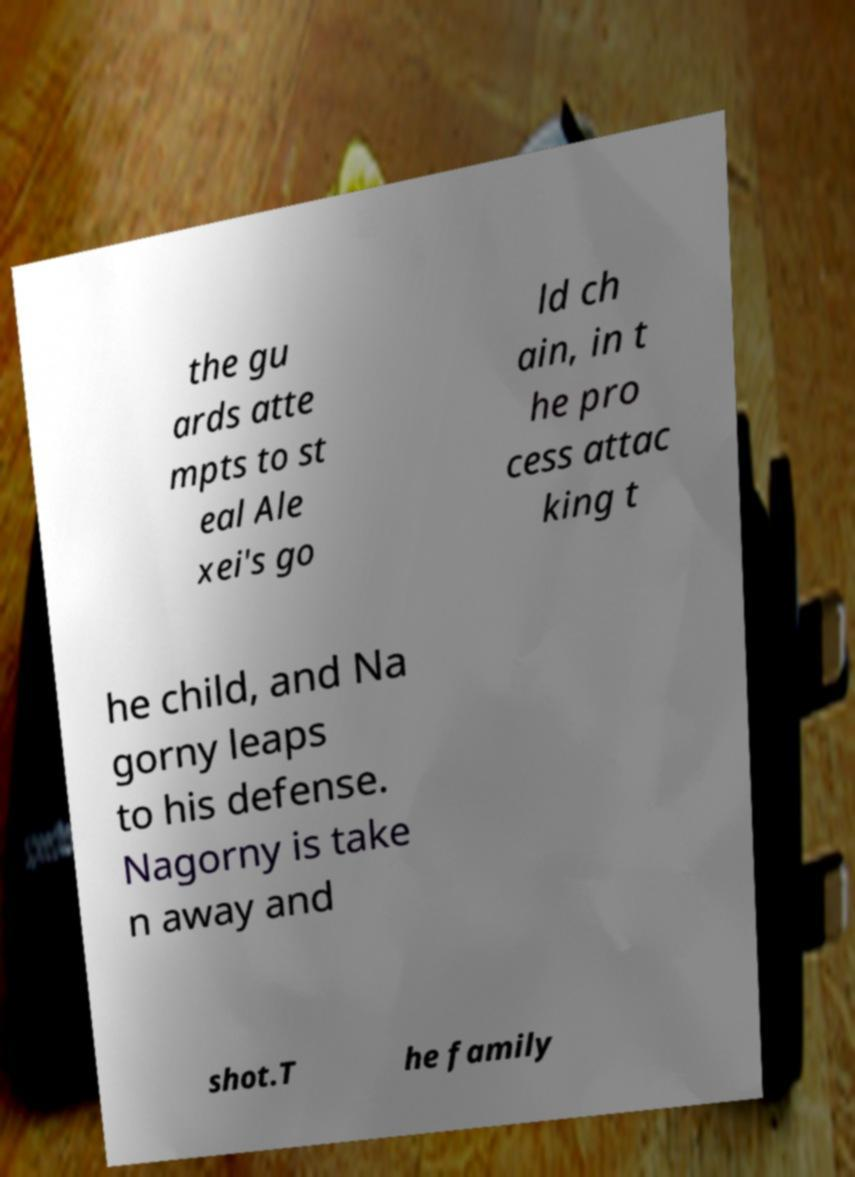Can you read and provide the text displayed in the image?This photo seems to have some interesting text. Can you extract and type it out for me? the gu ards atte mpts to st eal Ale xei's go ld ch ain, in t he pro cess attac king t he child, and Na gorny leaps to his defense. Nagorny is take n away and shot.T he family 